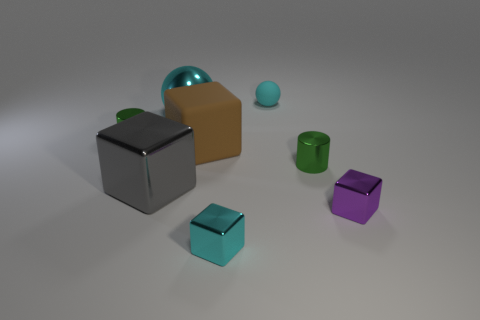There is a tiny cylinder in front of the tiny green cylinder behind the green metal cylinder that is right of the rubber sphere; what is its material? The tiny cylinder in front of the green cylinder and to the right of the rubber sphere appears to be made of the same material as the tiny green cylinder, which is closest in texture and shine to plastic. 